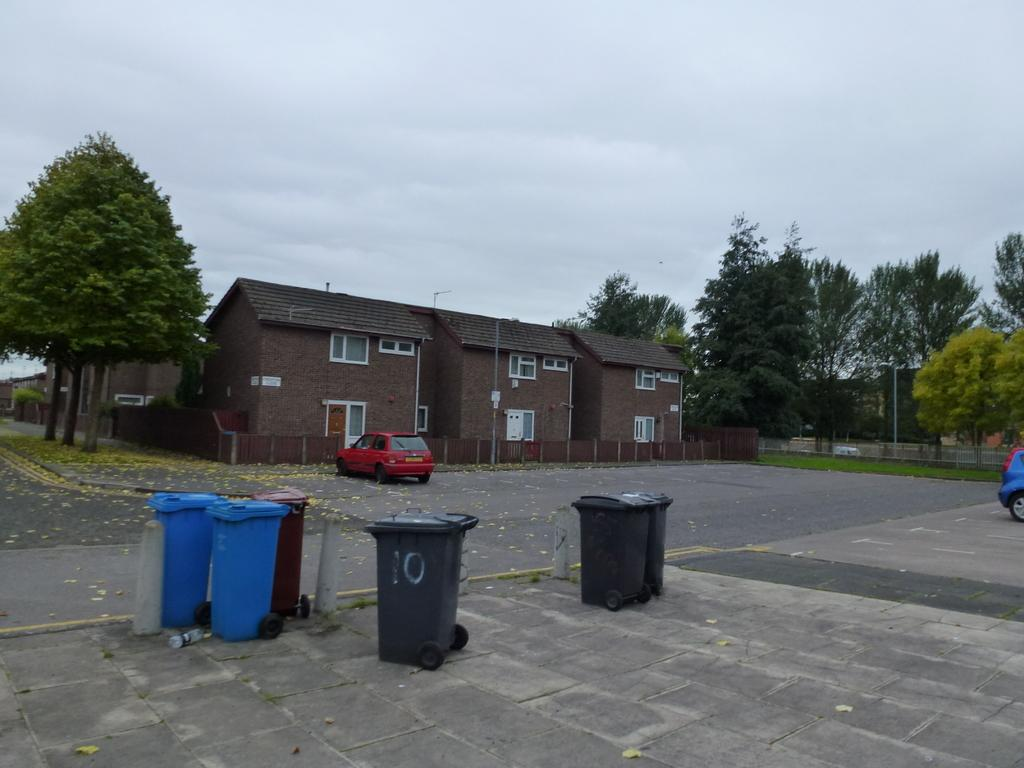<image>
Relay a brief, clear account of the picture shown. the number 10 is on the dark trash can 